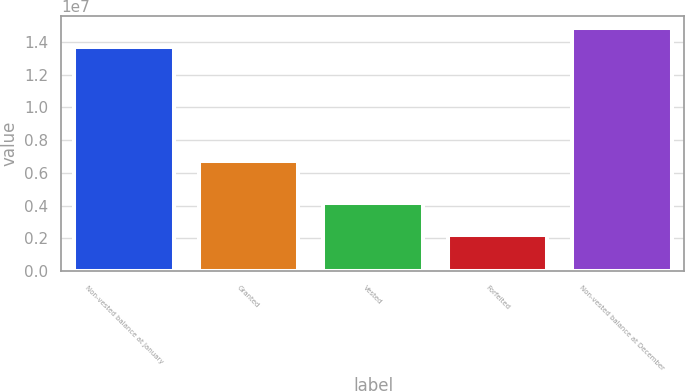Convert chart. <chart><loc_0><loc_0><loc_500><loc_500><bar_chart><fcel>Non-vested balance at January<fcel>Granted<fcel>Vested<fcel>Forfeited<fcel>Non-vested balance at December<nl><fcel>1.36745e+07<fcel>6.73401e+06<fcel>4.16421e+06<fcel>2.22401e+06<fcel>1.48541e+07<nl></chart> 